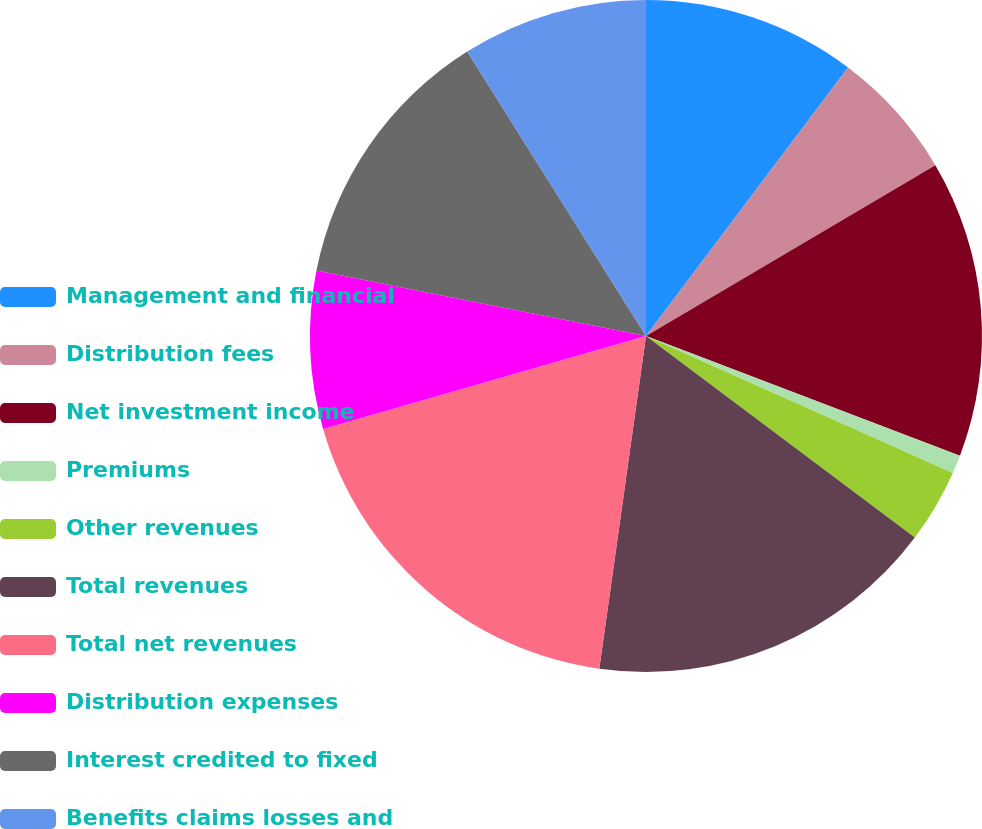Convert chart to OTSL. <chart><loc_0><loc_0><loc_500><loc_500><pie_chart><fcel>Management and financial<fcel>Distribution fees<fcel>Net investment income<fcel>Premiums<fcel>Other revenues<fcel>Total revenues<fcel>Total net revenues<fcel>Distribution expenses<fcel>Interest credited to fixed<fcel>Benefits claims losses and<nl><fcel>10.27%<fcel>6.24%<fcel>14.29%<fcel>0.88%<fcel>3.56%<fcel>16.98%<fcel>18.32%<fcel>7.58%<fcel>12.95%<fcel>8.93%<nl></chart> 